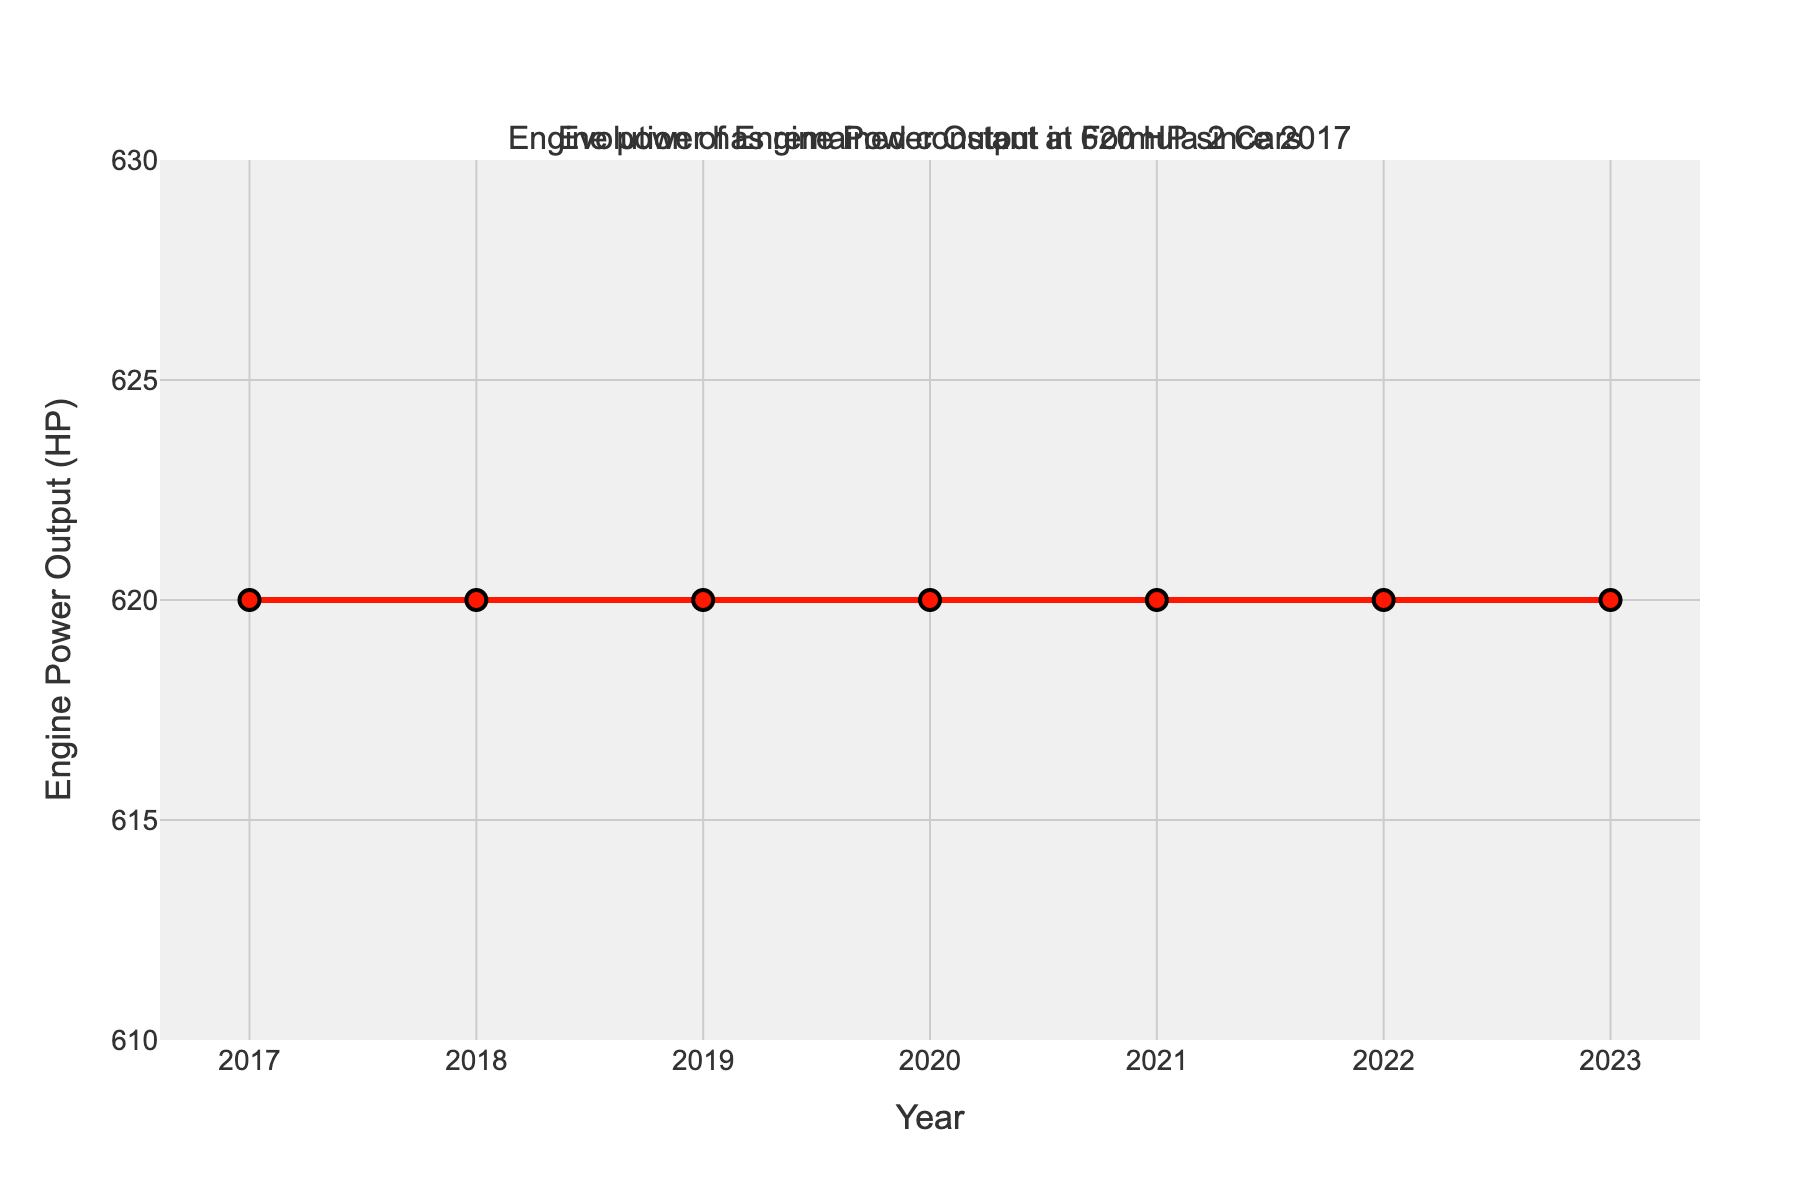What's the engine power output in any year from 2017 to 2023? The figure shows a line plot where the engine power output is constant over the years. From the plot, it’s clear that the power output remains at 620 HP throughout the shown period.
Answer: 620 HP Which year had the highest engine power output? The plot shows a flat line indicating that the engine power output is the same every year from 2017 to 2023. Since the output does not change, there is no single year with a higher value than another.
Answer: None, all years have the same output Has the engine power output changed over the observed period? The plot visually confirms that the engine power output has not changed since 2017, as it's a flat line across all years. Therefore, the engine power remained constant throughout the period.
Answer: No How many years are shown in the figure? To determine the number of years shown, count the data points on the horizontal axis from 2017 to 2023. This includes the years 2017, 2018, 2019, 2020, 2021, 2022, and 2023.
Answer: 7 years What color represents the engine power line in the plot? The plot uses a distinct color for the engine power line, which, as described, is red.
Answer: Red Is there any annotation in the plot? If yes, what does it say? Looking at the plot, there's a text annotation above or around the plot. It states that the engine power has remained constant at 620 HP since 2017.
Answer: Yes, "Engine power has remained constant at 620 HP since 2017" What is the range of the vertical axis in the plot? To find the range of the vertical axis, look at the y-axis labels. The plot shows engine power output between 610 HP and 630 HP.
Answer: 610 to 630 HP Do the markers on the line chart differ in size each year? By examining the plot, we see that the markers are uniform in size for each year, indicating a consistent representation.
Answer: No Calculate the total engine power output over the years from 2017 to 2023. To find the total, multiply the constant power output (620 HP) by the number of years (7). Therefore, 620 HP * 7 years = 4340 HP.
Answer: 4340 HP 